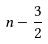<formula> <loc_0><loc_0><loc_500><loc_500>n - \frac { 3 } { 2 }</formula> 